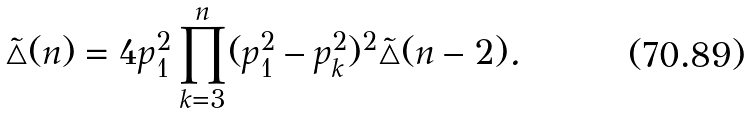<formula> <loc_0><loc_0><loc_500><loc_500>\tilde { \triangle } ( n ) = 4 p _ { 1 } ^ { 2 } \prod _ { k = 3 } ^ { n } ( p _ { 1 } ^ { 2 } - p _ { k } ^ { 2 } ) ^ { 2 } \tilde { \triangle } ( n - 2 ) .</formula> 